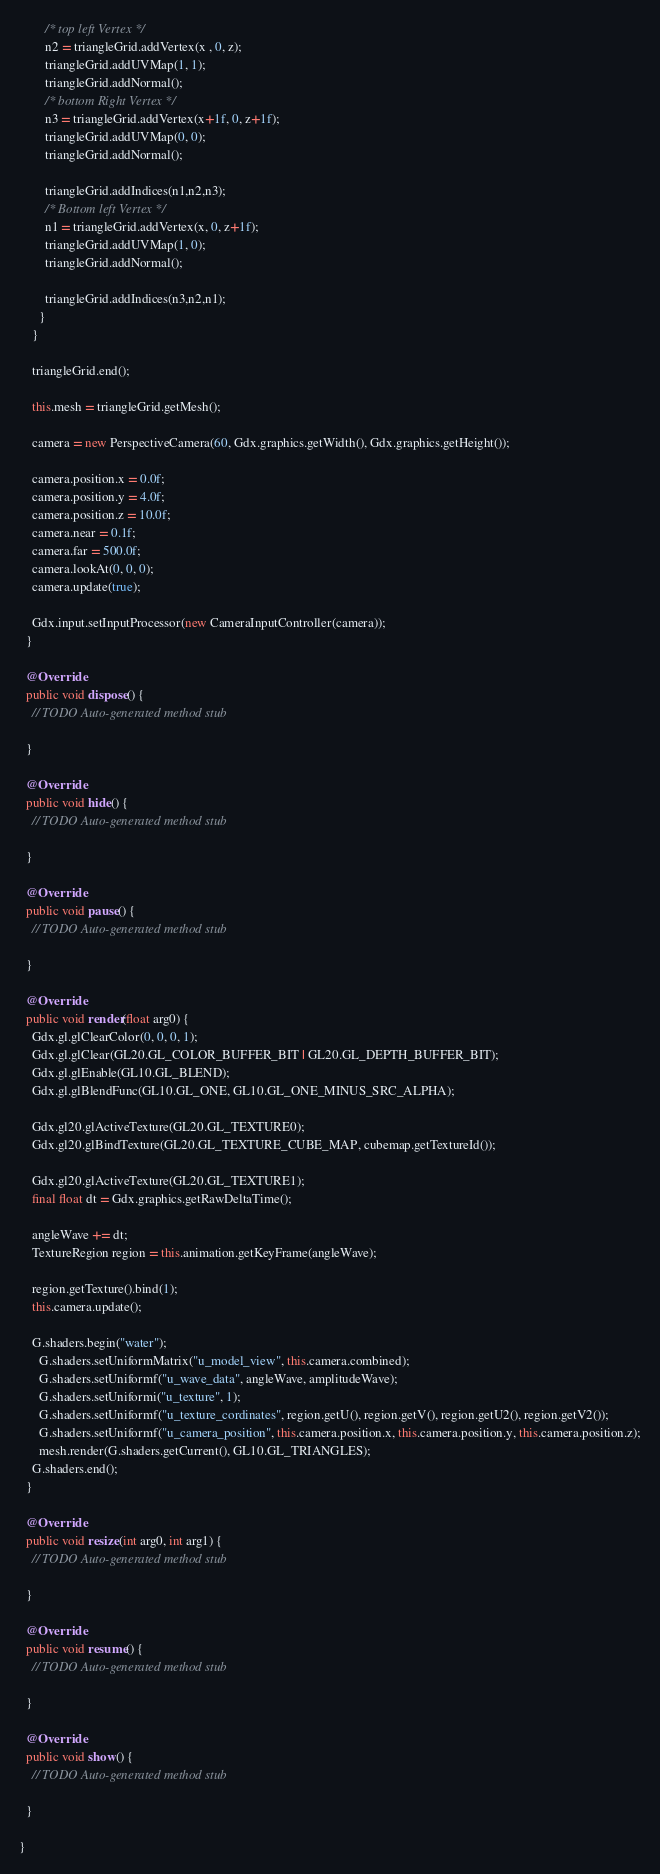<code> <loc_0><loc_0><loc_500><loc_500><_Java_>        /* top left Vertex */
        n2 = triangleGrid.addVertex(x , 0, z);
        triangleGrid.addUVMap(1, 1);
        triangleGrid.addNormal();
        /* bottom Right Vertex */
        n3 = triangleGrid.addVertex(x+1f, 0, z+1f);
        triangleGrid.addUVMap(0, 0);
        triangleGrid.addNormal();
        
        triangleGrid.addIndices(n1,n2,n3);
        /* Bottom left Vertex */
        n1 = triangleGrid.addVertex(x, 0, z+1f);
        triangleGrid.addUVMap(1, 0);
        triangleGrid.addNormal();
        
        triangleGrid.addIndices(n3,n2,n1);
      }
    }
    
    triangleGrid.end();

    this.mesh = triangleGrid.getMesh();
    
    camera = new PerspectiveCamera(60, Gdx.graphics.getWidth(), Gdx.graphics.getHeight());
    
    camera.position.x = 0.0f;
    camera.position.y = 4.0f;
    camera.position.z = 10.0f;
    camera.near = 0.1f;
    camera.far = 500.0f;
    camera.lookAt(0, 0, 0);
    camera.update(true);
    
    Gdx.input.setInputProcessor(new CameraInputController(camera));
  }

  @Override
  public void dispose() {
    // TODO Auto-generated method stub
    
  }
  
  @Override
  public void hide() {
    // TODO Auto-generated method stub
    
  }
  
  @Override
  public void pause() {
    // TODO Auto-generated method stub
    
  }
  
  @Override
  public void render(float arg0) {
    Gdx.gl.glClearColor(0, 0, 0, 1);
    Gdx.gl.glClear(GL20.GL_COLOR_BUFFER_BIT | GL20.GL_DEPTH_BUFFER_BIT);
    Gdx.gl.glEnable(GL10.GL_BLEND);
    Gdx.gl.glBlendFunc(GL10.GL_ONE, GL10.GL_ONE_MINUS_SRC_ALPHA);
    
    Gdx.gl20.glActiveTexture(GL20.GL_TEXTURE0);
    Gdx.gl20.glBindTexture(GL20.GL_TEXTURE_CUBE_MAP, cubemap.getTextureId());
    
    Gdx.gl20.glActiveTexture(GL20.GL_TEXTURE1);
    final float dt = Gdx.graphics.getRawDeltaTime();
    
    angleWave += dt;
    TextureRegion region = this.animation.getKeyFrame(angleWave);
    
    region.getTexture().bind(1);
    this.camera.update();
    
    G.shaders.begin("water");
      G.shaders.setUniformMatrix("u_model_view", this.camera.combined);
      G.shaders.setUniformf("u_wave_data", angleWave, amplitudeWave);
      G.shaders.setUniformi("u_texture", 1);
      G.shaders.setUniformf("u_texture_cordinates", region.getU(), region.getV(), region.getU2(), region.getV2());
      G.shaders.setUniformf("u_camera_position", this.camera.position.x, this.camera.position.y, this.camera.position.z);
      mesh.render(G.shaders.getCurrent(), GL10.GL_TRIANGLES);
    G.shaders.end();
  }
  
  @Override
  public void resize(int arg0, int arg1) {
    // TODO Auto-generated method stub
    
  }
  
  @Override
  public void resume() {
    // TODO Auto-generated method stub
    
  }
  
  @Override
  public void show() {
    // TODO Auto-generated method stub
    
  }
  
}
</code> 